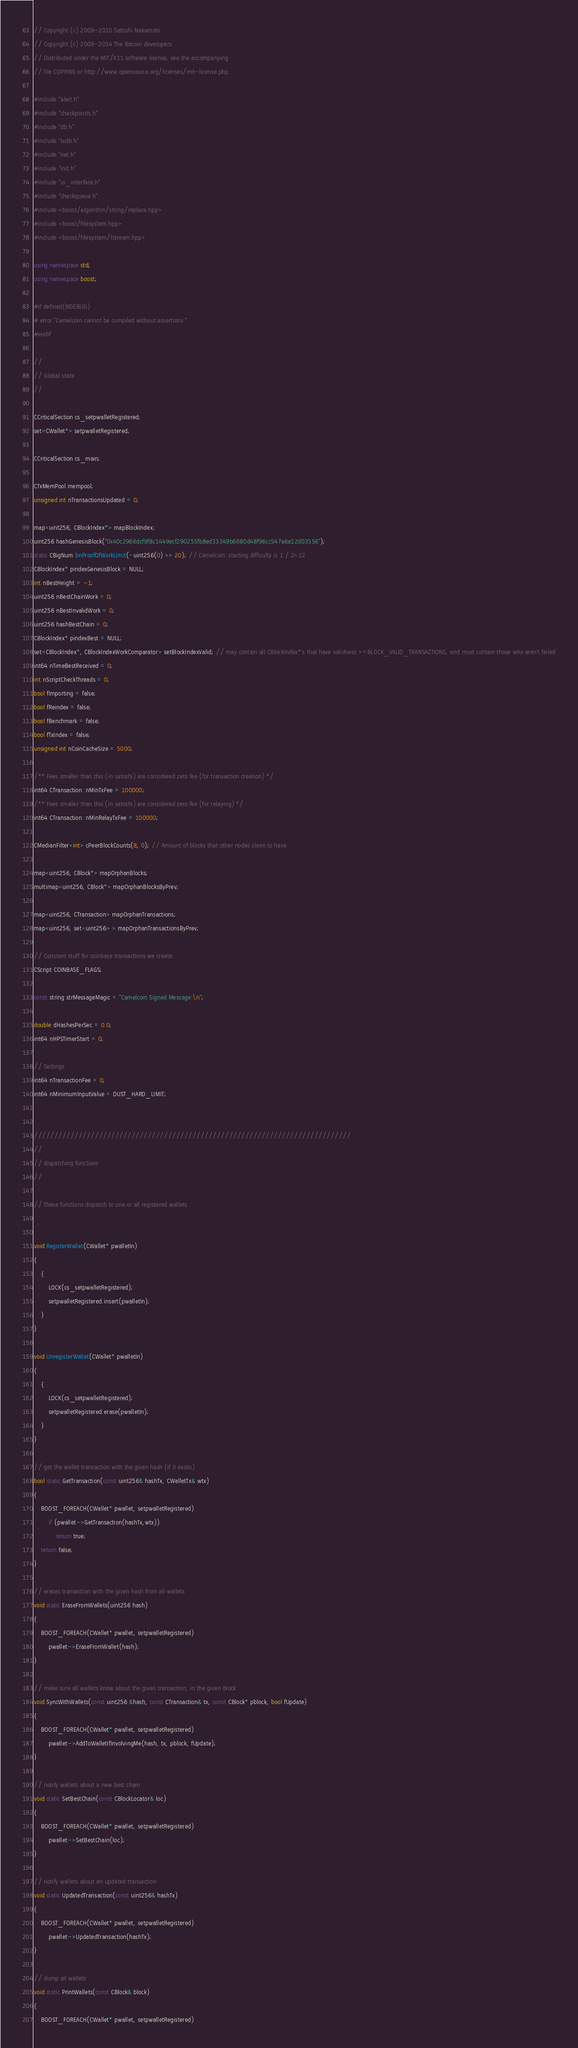<code> <loc_0><loc_0><loc_500><loc_500><_C++_>// Copyright (c) 2009-2010 Satoshi Nakamoto
// Copyright (c) 2009-2014 The Bitcoin developers
// Distributed under the MIT/X11 software license, see the accompanying
// file COPYING or http://www.opensource.org/licenses/mit-license.php.

#include "alert.h"
#include "checkpoints.h"
#include "db.h"
#include "txdb.h"
#include "net.h"
#include "init.h"
#include "ui_interface.h"
#include "checkqueue.h"
#include <boost/algorithm/string/replace.hpp>
#include <boost/filesystem.hpp>
#include <boost/filesystem/fstream.hpp>

using namespace std;
using namespace boost;

#if defined(NDEBUG)
# error "Camelcoin cannot be compiled without assertions."
#endif

//
// Global state
//

CCriticalSection cs_setpwalletRegistered;
set<CWallet*> setpwalletRegistered;

CCriticalSection cs_main;

CTxMemPool mempool;
unsigned int nTransactionsUpdated = 0;

map<uint256, CBlockIndex*> mapBlockIndex;
uint256 hashGenesisBlock("0x40c2966dcf9f8c1449ecf290255fb8ed33349b6680d48f96cc547a6a12d03556");
static CBigNum bnProofOfWorkLimit(~uint256(0) >> 20); // Camelcoin: starting difficulty is 1 / 2^12
CBlockIndex* pindexGenesisBlock = NULL;
int nBestHeight = -1;
uint256 nBestChainWork = 0;
uint256 nBestInvalidWork = 0;
uint256 hashBestChain = 0;
CBlockIndex* pindexBest = NULL;
set<CBlockIndex*, CBlockIndexWorkComparator> setBlockIndexValid; // may contain all CBlockIndex*'s that have validness >=BLOCK_VALID_TRANSACTIONS, and must contain those who aren't failed
int64 nTimeBestReceived = 0;
int nScriptCheckThreads = 0;
bool fImporting = false;
bool fReindex = false;
bool fBenchmark = false;
bool fTxIndex = false;
unsigned int nCoinCacheSize = 5000;

/** Fees smaller than this (in satoshi) are considered zero fee (for transaction creation) */
int64 CTransaction::nMinTxFee = 100000;
/** Fees smaller than this (in satoshi) are considered zero fee (for relaying) */
int64 CTransaction::nMinRelayTxFee = 100000;

CMedianFilter<int> cPeerBlockCounts(8, 0); // Amount of blocks that other nodes claim to have

map<uint256, CBlock*> mapOrphanBlocks;
multimap<uint256, CBlock*> mapOrphanBlocksByPrev;

map<uint256, CTransaction> mapOrphanTransactions;
map<uint256, set<uint256> > mapOrphanTransactionsByPrev;

// Constant stuff for coinbase transactions we create:
CScript COINBASE_FLAGS;

const string strMessageMagic = "Camelcoin Signed Message:\n";

double dHashesPerSec = 0.0;
int64 nHPSTimerStart = 0;

// Settings
int64 nTransactionFee = 0;
int64 nMinimumInputValue = DUST_HARD_LIMIT;


//////////////////////////////////////////////////////////////////////////////
//
// dispatching functions
//

// These functions dispatch to one or all registered wallets


void RegisterWallet(CWallet* pwalletIn)
{
    {
        LOCK(cs_setpwalletRegistered);
        setpwalletRegistered.insert(pwalletIn);
    }
}

void UnregisterWallet(CWallet* pwalletIn)
{
    {
        LOCK(cs_setpwalletRegistered);
        setpwalletRegistered.erase(pwalletIn);
    }
}

// get the wallet transaction with the given hash (if it exists)
bool static GetTransaction(const uint256& hashTx, CWalletTx& wtx)
{
    BOOST_FOREACH(CWallet* pwallet, setpwalletRegistered)
        if (pwallet->GetTransaction(hashTx,wtx))
            return true;
    return false;
}

// erases transaction with the given hash from all wallets
void static EraseFromWallets(uint256 hash)
{
    BOOST_FOREACH(CWallet* pwallet, setpwalletRegistered)
        pwallet->EraseFromWallet(hash);
}

// make sure all wallets know about the given transaction, in the given block
void SyncWithWallets(const uint256 &hash, const CTransaction& tx, const CBlock* pblock, bool fUpdate)
{
    BOOST_FOREACH(CWallet* pwallet, setpwalletRegistered)
        pwallet->AddToWalletIfInvolvingMe(hash, tx, pblock, fUpdate);
}

// notify wallets about a new best chain
void static SetBestChain(const CBlockLocator& loc)
{
    BOOST_FOREACH(CWallet* pwallet, setpwalletRegistered)
        pwallet->SetBestChain(loc);
}

// notify wallets about an updated transaction
void static UpdatedTransaction(const uint256& hashTx)
{
    BOOST_FOREACH(CWallet* pwallet, setpwalletRegistered)
        pwallet->UpdatedTransaction(hashTx);
}

// dump all wallets
void static PrintWallets(const CBlock& block)
{
    BOOST_FOREACH(CWallet* pwallet, setpwalletRegistered)</code> 